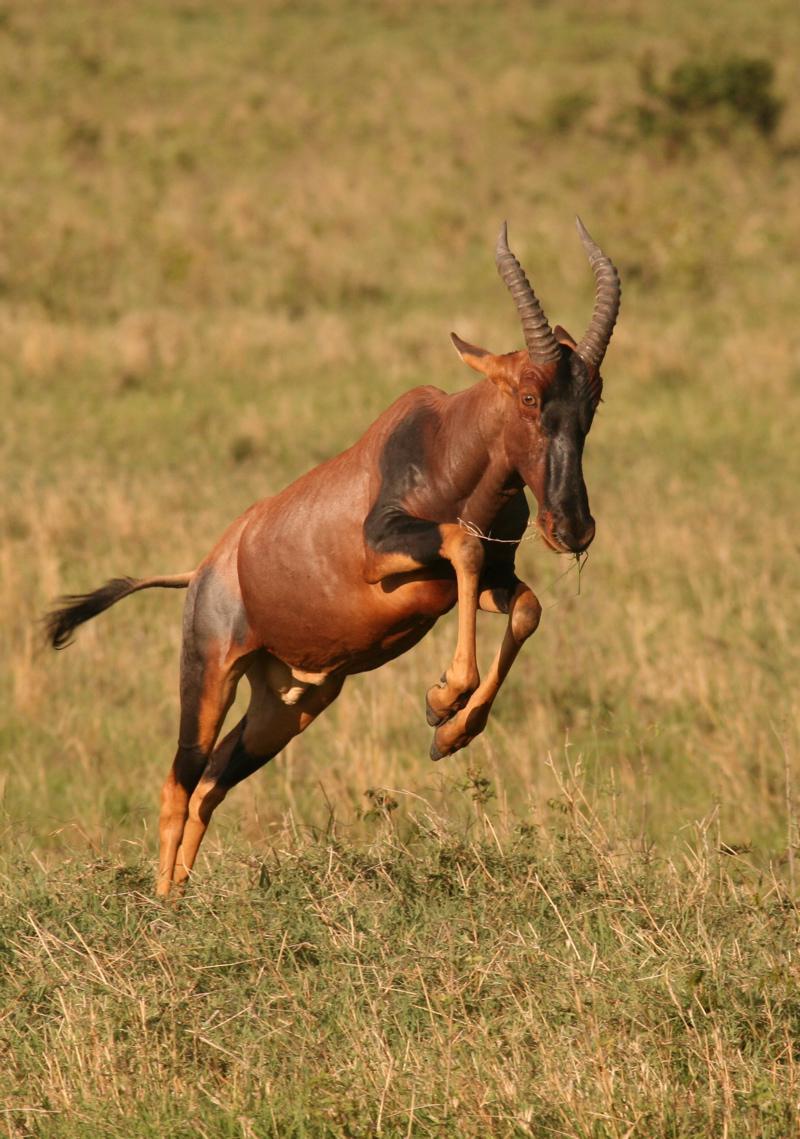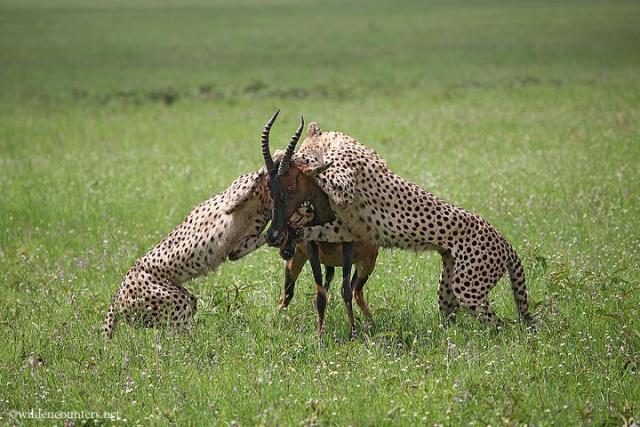The first image is the image on the left, the second image is the image on the right. Evaluate the accuracy of this statement regarding the images: "The right image contains at least three hartebeest's.". Is it true? Answer yes or no. No. The first image is the image on the left, the second image is the image on the right. For the images shown, is this caption "All hooved animals in one image have both front legs off the ground." true? Answer yes or no. Yes. 